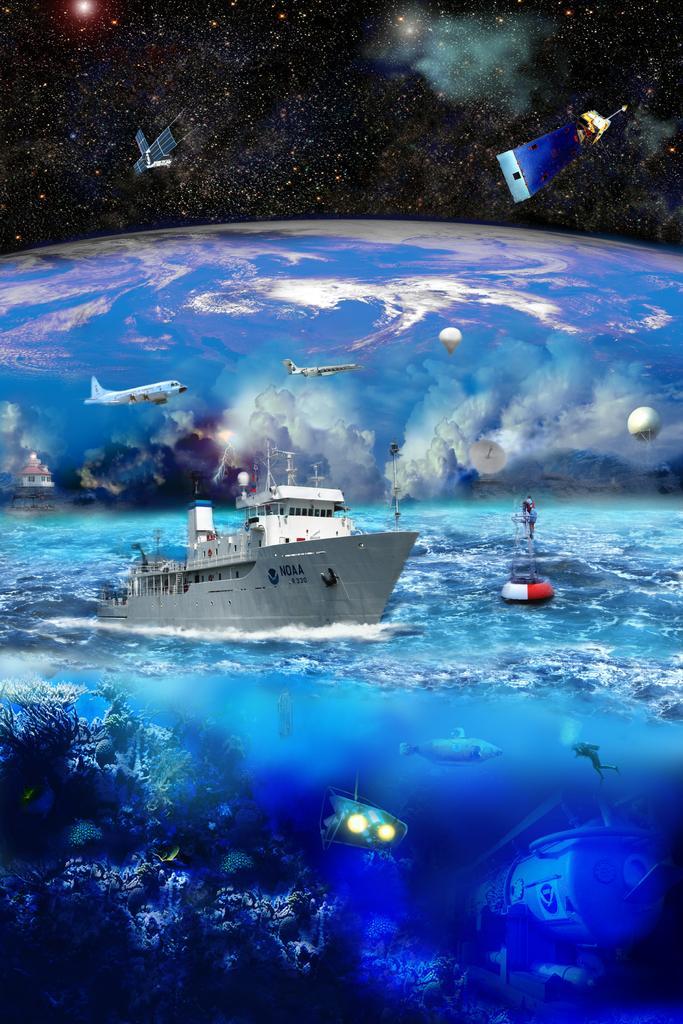How would you summarize this image in a sentence or two? In the image we can see a ship in the water, there is an airplane, satellite, hot air balloon, water marine, building, galaxy and a cloudy sky. 